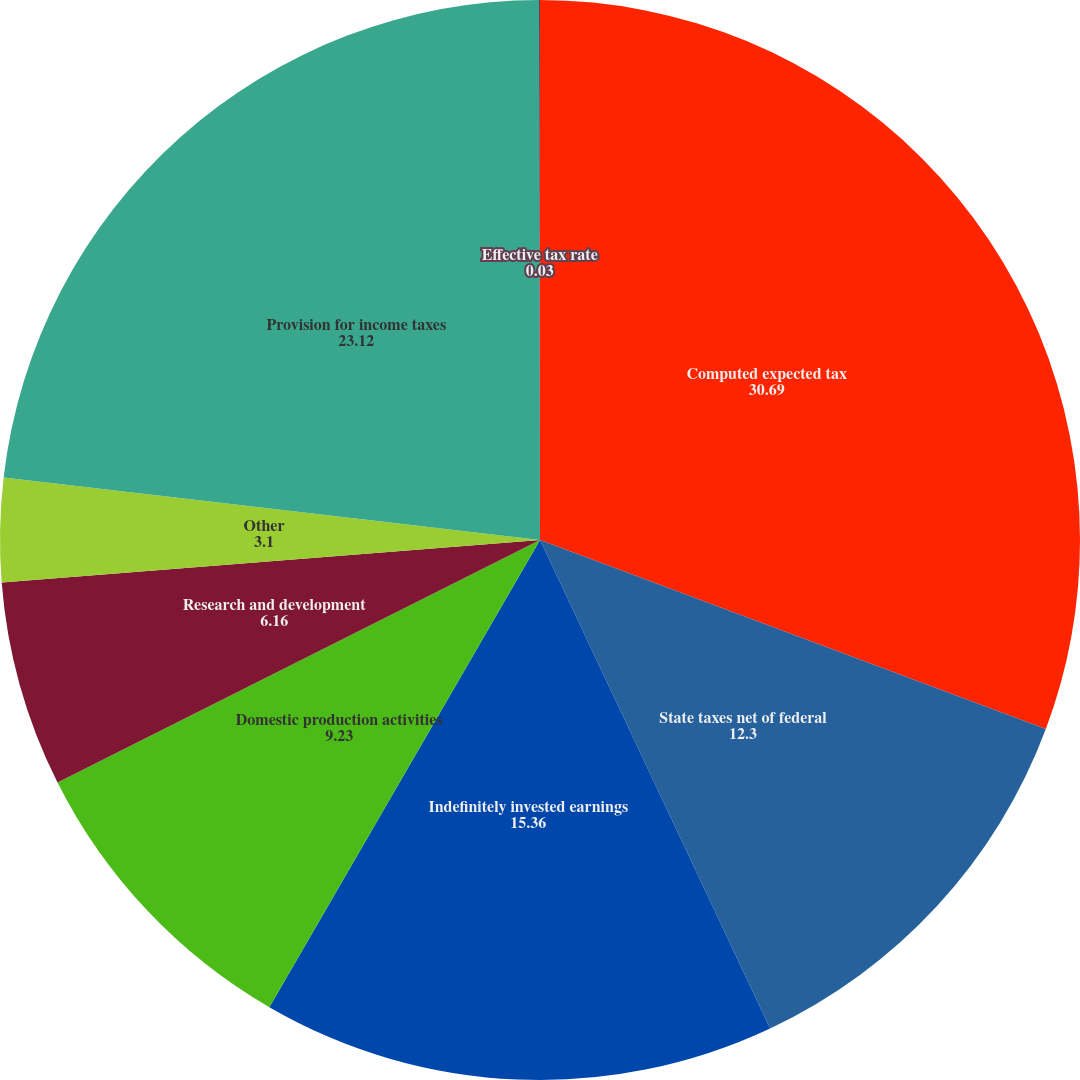Convert chart to OTSL. <chart><loc_0><loc_0><loc_500><loc_500><pie_chart><fcel>Computed expected tax<fcel>State taxes net of federal<fcel>Indefinitely invested earnings<fcel>Domestic production activities<fcel>Research and development<fcel>Other<fcel>Provision for income taxes<fcel>Effective tax rate<nl><fcel>30.69%<fcel>12.3%<fcel>15.36%<fcel>9.23%<fcel>6.16%<fcel>3.1%<fcel>23.12%<fcel>0.03%<nl></chart> 